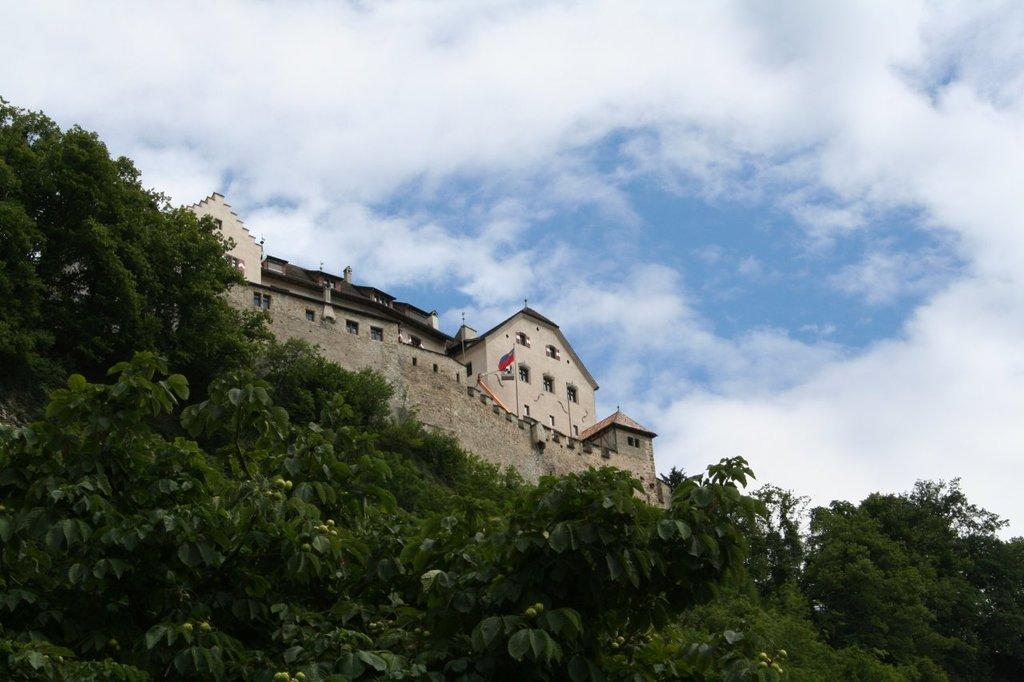What can be seen in the background of the image? In the background of the image, there is a sky with clouds visible. What type of vegetation is present in the image? Trees are present in the image. What architectural feature is visible in the image? Windows are present in the image. How many buildings can be seen in the image? There is one building visible in the image. What additional element is present in the image? A flag is visible in the image. What type of nose can be seen on the tree in the image? There is no nose present on the tree in the image; it is a natural object and does not have facial features. 